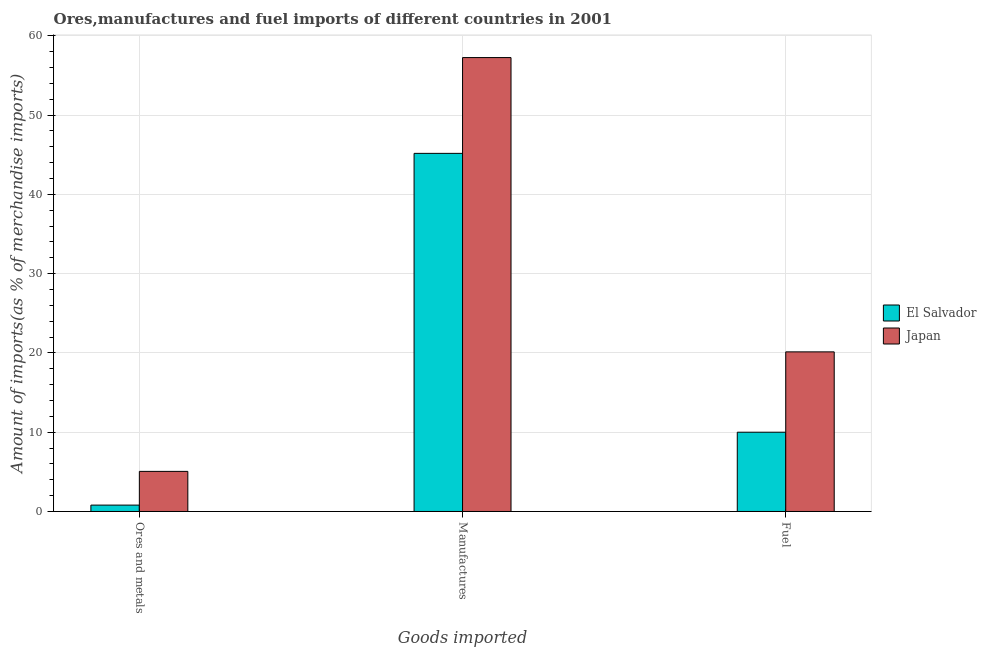How many bars are there on the 3rd tick from the left?
Offer a terse response. 2. How many bars are there on the 1st tick from the right?
Your response must be concise. 2. What is the label of the 2nd group of bars from the left?
Keep it short and to the point. Manufactures. What is the percentage of ores and metals imports in Japan?
Make the answer very short. 5.06. Across all countries, what is the maximum percentage of manufactures imports?
Make the answer very short. 57.25. Across all countries, what is the minimum percentage of ores and metals imports?
Provide a succinct answer. 0.8. In which country was the percentage of manufactures imports minimum?
Your response must be concise. El Salvador. What is the total percentage of manufactures imports in the graph?
Make the answer very short. 102.42. What is the difference between the percentage of manufactures imports in Japan and that in El Salvador?
Provide a succinct answer. 12.08. What is the difference between the percentage of fuel imports in Japan and the percentage of manufactures imports in El Salvador?
Give a very brief answer. -25.04. What is the average percentage of ores and metals imports per country?
Provide a succinct answer. 2.93. What is the difference between the percentage of manufactures imports and percentage of fuel imports in El Salvador?
Your response must be concise. 35.17. What is the ratio of the percentage of fuel imports in El Salvador to that in Japan?
Offer a terse response. 0.5. Is the percentage of manufactures imports in El Salvador less than that in Japan?
Offer a very short reply. Yes. Is the difference between the percentage of manufactures imports in Japan and El Salvador greater than the difference between the percentage of fuel imports in Japan and El Salvador?
Your response must be concise. Yes. What is the difference between the highest and the second highest percentage of ores and metals imports?
Offer a very short reply. 4.25. What is the difference between the highest and the lowest percentage of fuel imports?
Your answer should be compact. 10.13. Is the sum of the percentage of manufactures imports in Japan and El Salvador greater than the maximum percentage of fuel imports across all countries?
Give a very brief answer. Yes. What does the 1st bar from the left in Manufactures represents?
Provide a succinct answer. El Salvador. Are all the bars in the graph horizontal?
Your response must be concise. No. What is the difference between two consecutive major ticks on the Y-axis?
Keep it short and to the point. 10. Are the values on the major ticks of Y-axis written in scientific E-notation?
Make the answer very short. No. Does the graph contain grids?
Give a very brief answer. Yes. Where does the legend appear in the graph?
Keep it short and to the point. Center right. What is the title of the graph?
Ensure brevity in your answer.  Ores,manufactures and fuel imports of different countries in 2001. Does "Burkina Faso" appear as one of the legend labels in the graph?
Make the answer very short. No. What is the label or title of the X-axis?
Ensure brevity in your answer.  Goods imported. What is the label or title of the Y-axis?
Provide a short and direct response. Amount of imports(as % of merchandise imports). What is the Amount of imports(as % of merchandise imports) in El Salvador in Ores and metals?
Provide a short and direct response. 0.8. What is the Amount of imports(as % of merchandise imports) of Japan in Ores and metals?
Your answer should be compact. 5.06. What is the Amount of imports(as % of merchandise imports) of El Salvador in Manufactures?
Your answer should be compact. 45.17. What is the Amount of imports(as % of merchandise imports) of Japan in Manufactures?
Your answer should be compact. 57.25. What is the Amount of imports(as % of merchandise imports) in El Salvador in Fuel?
Ensure brevity in your answer.  10. What is the Amount of imports(as % of merchandise imports) in Japan in Fuel?
Your answer should be very brief. 20.13. Across all Goods imported, what is the maximum Amount of imports(as % of merchandise imports) of El Salvador?
Your response must be concise. 45.17. Across all Goods imported, what is the maximum Amount of imports(as % of merchandise imports) in Japan?
Make the answer very short. 57.25. Across all Goods imported, what is the minimum Amount of imports(as % of merchandise imports) of El Salvador?
Your answer should be compact. 0.8. Across all Goods imported, what is the minimum Amount of imports(as % of merchandise imports) in Japan?
Make the answer very short. 5.06. What is the total Amount of imports(as % of merchandise imports) of El Salvador in the graph?
Give a very brief answer. 55.97. What is the total Amount of imports(as % of merchandise imports) in Japan in the graph?
Provide a succinct answer. 82.44. What is the difference between the Amount of imports(as % of merchandise imports) in El Salvador in Ores and metals and that in Manufactures?
Provide a short and direct response. -44.37. What is the difference between the Amount of imports(as % of merchandise imports) of Japan in Ores and metals and that in Manufactures?
Your answer should be very brief. -52.19. What is the difference between the Amount of imports(as % of merchandise imports) in El Salvador in Ores and metals and that in Fuel?
Your answer should be compact. -9.19. What is the difference between the Amount of imports(as % of merchandise imports) of Japan in Ores and metals and that in Fuel?
Your answer should be very brief. -15.07. What is the difference between the Amount of imports(as % of merchandise imports) of El Salvador in Manufactures and that in Fuel?
Offer a terse response. 35.17. What is the difference between the Amount of imports(as % of merchandise imports) of Japan in Manufactures and that in Fuel?
Keep it short and to the point. 37.12. What is the difference between the Amount of imports(as % of merchandise imports) in El Salvador in Ores and metals and the Amount of imports(as % of merchandise imports) in Japan in Manufactures?
Make the answer very short. -56.45. What is the difference between the Amount of imports(as % of merchandise imports) in El Salvador in Ores and metals and the Amount of imports(as % of merchandise imports) in Japan in Fuel?
Make the answer very short. -19.33. What is the difference between the Amount of imports(as % of merchandise imports) in El Salvador in Manufactures and the Amount of imports(as % of merchandise imports) in Japan in Fuel?
Offer a very short reply. 25.04. What is the average Amount of imports(as % of merchandise imports) of El Salvador per Goods imported?
Ensure brevity in your answer.  18.66. What is the average Amount of imports(as % of merchandise imports) of Japan per Goods imported?
Keep it short and to the point. 27.48. What is the difference between the Amount of imports(as % of merchandise imports) in El Salvador and Amount of imports(as % of merchandise imports) in Japan in Ores and metals?
Offer a terse response. -4.25. What is the difference between the Amount of imports(as % of merchandise imports) in El Salvador and Amount of imports(as % of merchandise imports) in Japan in Manufactures?
Offer a very short reply. -12.08. What is the difference between the Amount of imports(as % of merchandise imports) of El Salvador and Amount of imports(as % of merchandise imports) of Japan in Fuel?
Offer a very short reply. -10.13. What is the ratio of the Amount of imports(as % of merchandise imports) of El Salvador in Ores and metals to that in Manufactures?
Keep it short and to the point. 0.02. What is the ratio of the Amount of imports(as % of merchandise imports) in Japan in Ores and metals to that in Manufactures?
Offer a very short reply. 0.09. What is the ratio of the Amount of imports(as % of merchandise imports) in El Salvador in Ores and metals to that in Fuel?
Offer a very short reply. 0.08. What is the ratio of the Amount of imports(as % of merchandise imports) of Japan in Ores and metals to that in Fuel?
Offer a terse response. 0.25. What is the ratio of the Amount of imports(as % of merchandise imports) of El Salvador in Manufactures to that in Fuel?
Your answer should be very brief. 4.52. What is the ratio of the Amount of imports(as % of merchandise imports) in Japan in Manufactures to that in Fuel?
Offer a terse response. 2.84. What is the difference between the highest and the second highest Amount of imports(as % of merchandise imports) in El Salvador?
Provide a short and direct response. 35.17. What is the difference between the highest and the second highest Amount of imports(as % of merchandise imports) in Japan?
Provide a succinct answer. 37.12. What is the difference between the highest and the lowest Amount of imports(as % of merchandise imports) of El Salvador?
Give a very brief answer. 44.37. What is the difference between the highest and the lowest Amount of imports(as % of merchandise imports) in Japan?
Give a very brief answer. 52.19. 